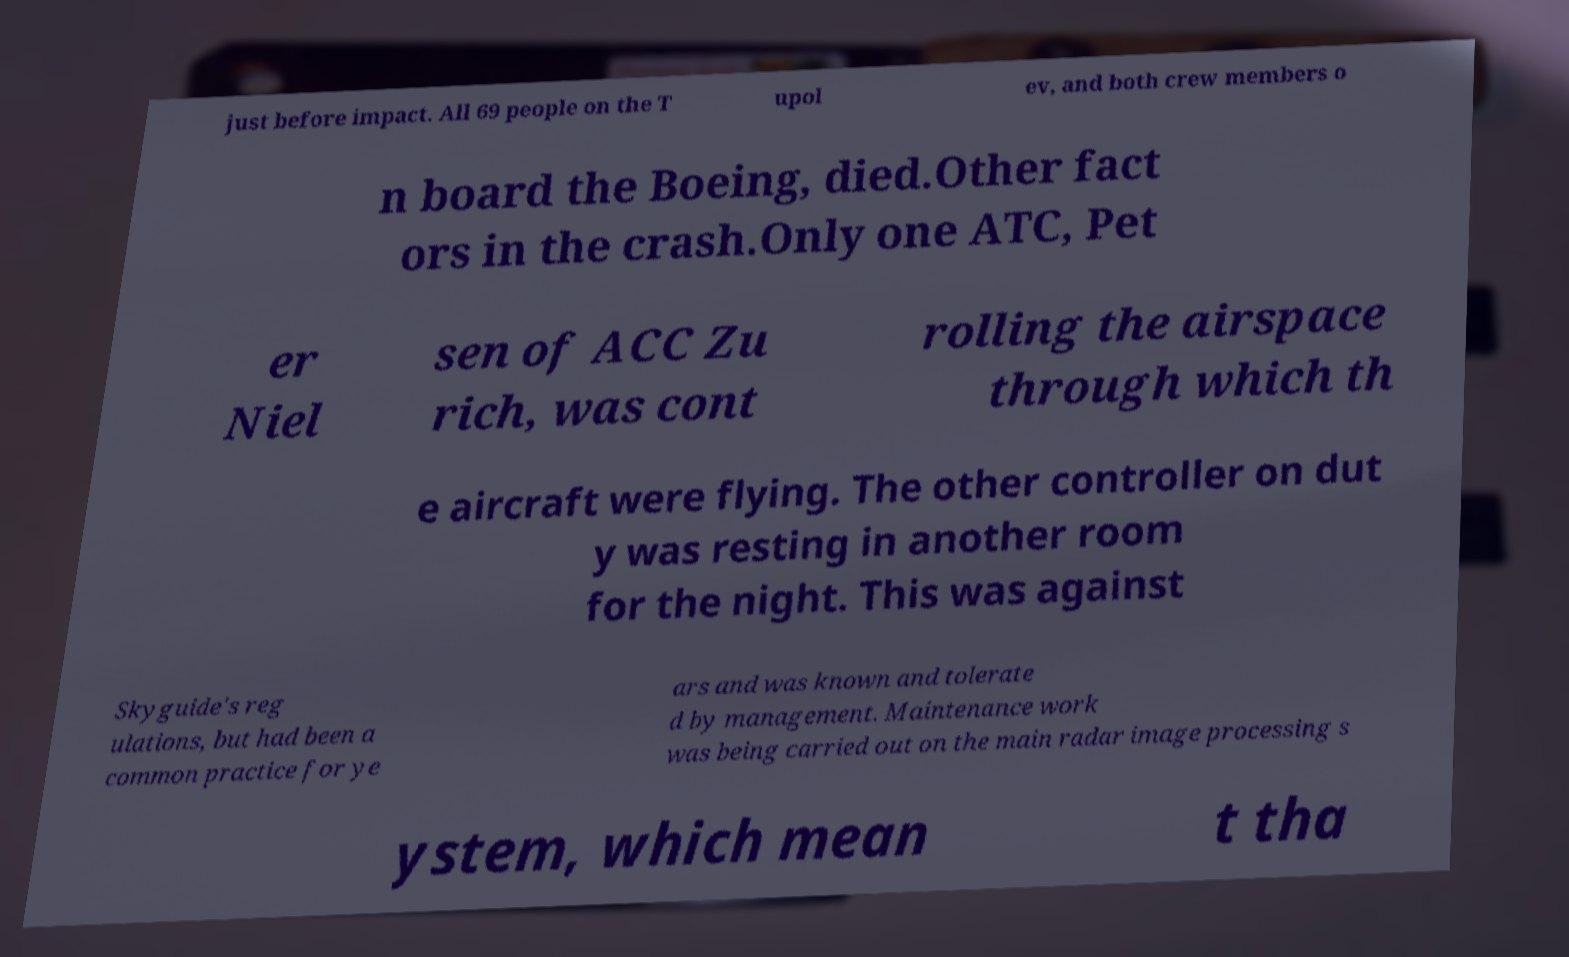For documentation purposes, I need the text within this image transcribed. Could you provide that? just before impact. All 69 people on the T upol ev, and both crew members o n board the Boeing, died.Other fact ors in the crash.Only one ATC, Pet er Niel sen of ACC Zu rich, was cont rolling the airspace through which th e aircraft were flying. The other controller on dut y was resting in another room for the night. This was against Skyguide's reg ulations, but had been a common practice for ye ars and was known and tolerate d by management. Maintenance work was being carried out on the main radar image processing s ystem, which mean t tha 